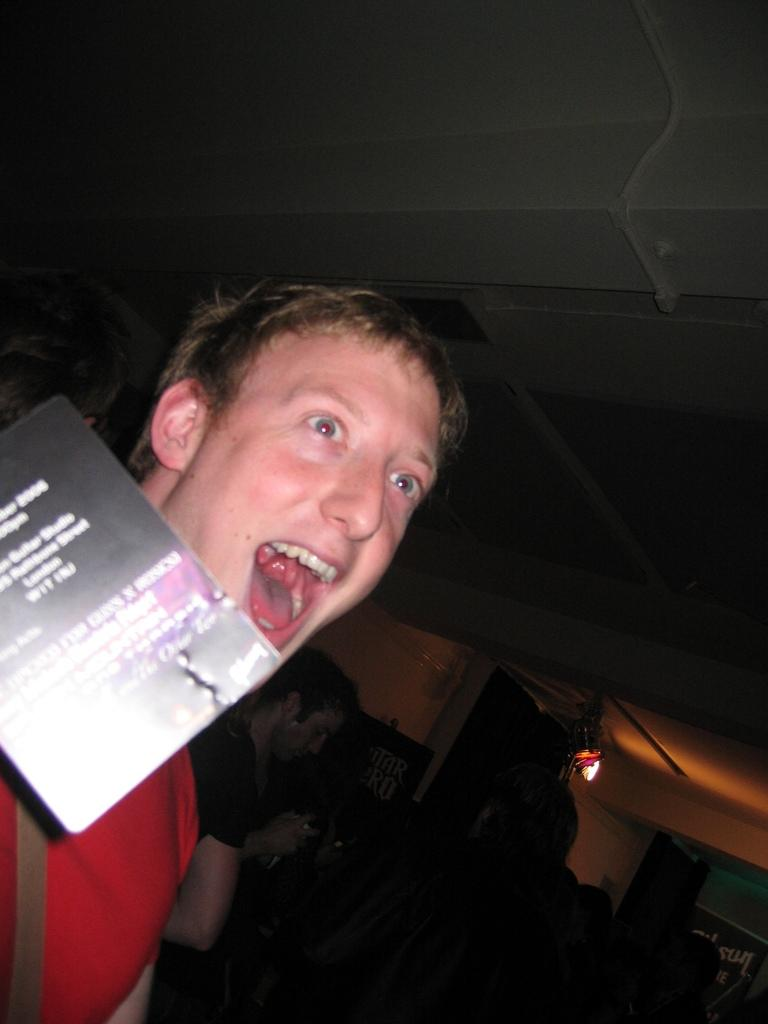What is located on the left side of the image? There is a person and a poster on the left side of the image. What can be seen in the background of the image? There are people, hoardings, and walls in the background of the image. What type of hall can be seen in the image? There is no hall present in the image. Is the image taken during the night? The time of day cannot be determined from the image. 